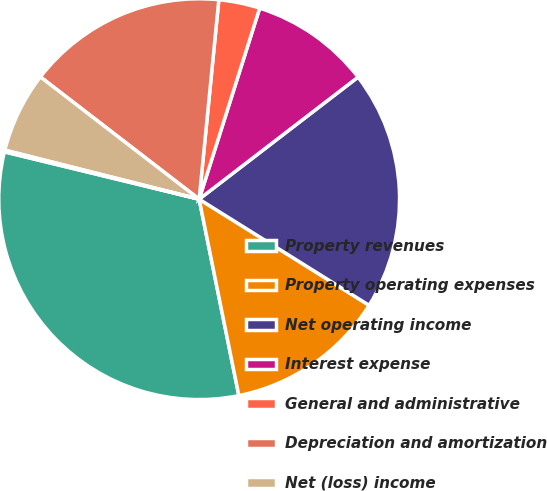Convert chart to OTSL. <chart><loc_0><loc_0><loc_500><loc_500><pie_chart><fcel>Property revenues<fcel>Property operating expenses<fcel>Net operating income<fcel>Interest expense<fcel>General and administrative<fcel>Depreciation and amortization<fcel>Net (loss) income<fcel>Company's share of net (loss)<nl><fcel>31.97%<fcel>12.94%<fcel>19.31%<fcel>9.69%<fcel>3.32%<fcel>16.12%<fcel>6.51%<fcel>0.14%<nl></chart> 